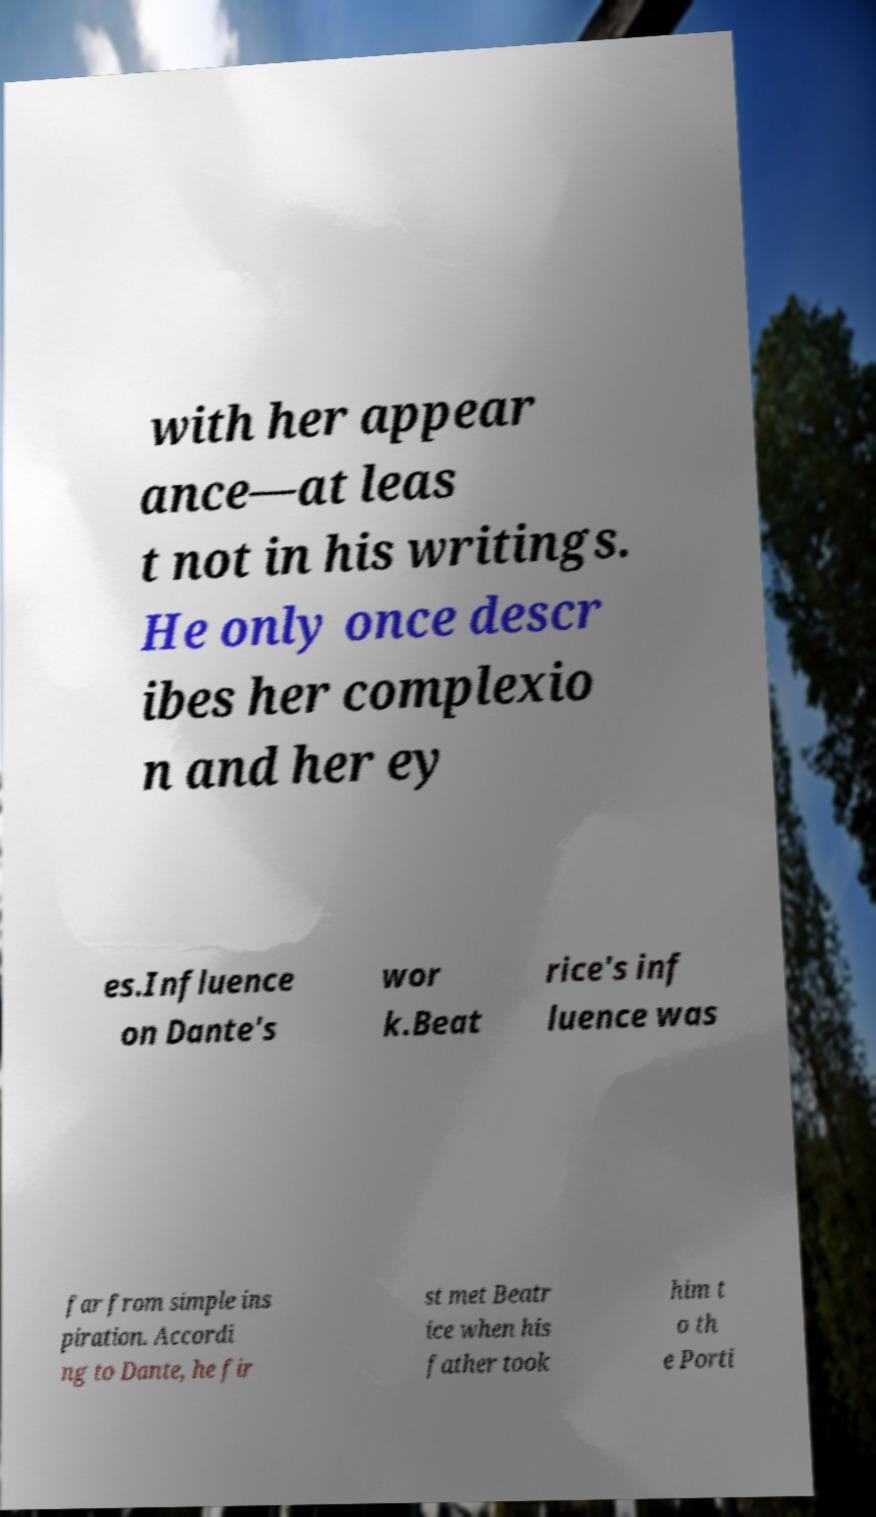Could you extract and type out the text from this image? with her appear ance—at leas t not in his writings. He only once descr ibes her complexio n and her ey es.Influence on Dante's wor k.Beat rice's inf luence was far from simple ins piration. Accordi ng to Dante, he fir st met Beatr ice when his father took him t o th e Porti 